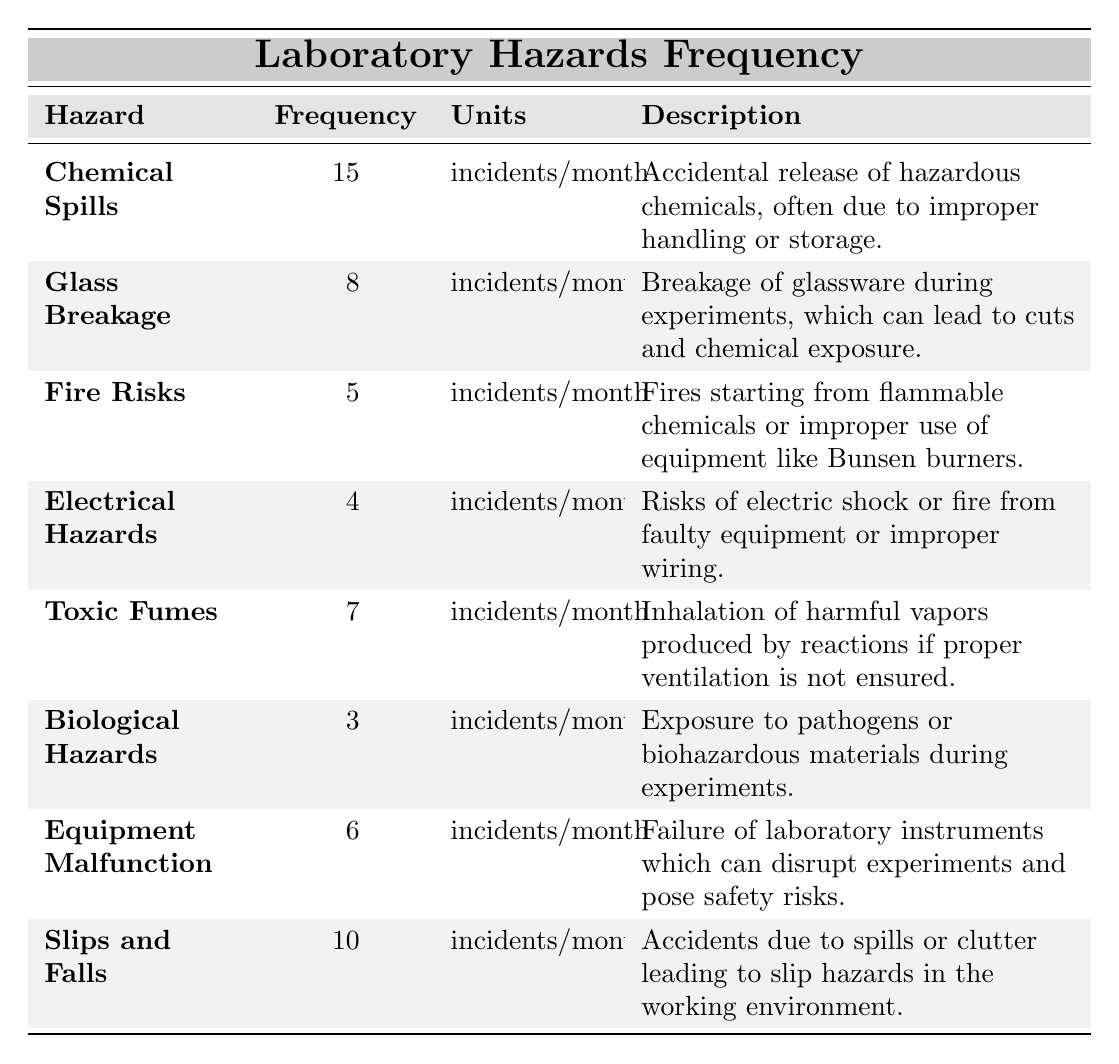What is the most frequent laboratory hazard? The table shows that "Chemical Spills" have the highest frequency at 15 incidents per month.
Answer: Chemical Spills How many incidents of "Glass Breakage" are reported each month? The table indicates that there are 8 incidents of "Glass Breakage" each month.
Answer: 8 incidents Are "Electrical Hazards" more frequent than "Fire Risks"? "Electrical Hazards" occur 4 times per month, while "Fire Risks" occur 5 times per month, thus "Electrical Hazards" are not more frequent.
Answer: No What is the total number of incidents for the top three hazards? The top three hazards are "Chemical Spills" (15), "Slips and Falls" (10), and "Glass Breakage" (8). Total incidents = 15 + 10 + 8 = 33.
Answer: 33 What is the frequency of "Toxic Fumes"? The table states that "Toxic Fumes" have a frequency of 7 incidents per month.
Answer: 7 incidents Which hazard has the lowest frequency and what is its value? The lowest frequency is for "Biological Hazards," which is reported at 3 incidents per month.
Answer: 3 incidents What is the average frequency of all hazards listed? To find the average, sum all frequencies: 15 + 8 + 5 + 4 + 7 + 3 + 6 + 10 = 58. There are 8 hazards, so the average is 58 / 8 = 7.25.
Answer: 7.25 incidents Is the frequency of "Equipment Malfunction" greater than or equal to the sum of "Fire Risks" and "Electrical Hazards"? "Equipment Malfunction" has a frequency of 6, while "Fire Risks" (5) + "Electrical Hazards" (4) sum to 9. Therefore, 6 is less than 9.
Answer: No How many more incidents occur from "Slips and Falls" than from "Biological Hazards"? "Slips and Falls" have 10 incidents, while "Biological Hazards" have 3 incidents. The difference is 10 - 3 = 7 incidents.
Answer: 7 incidents What percentage of the total incidents does "Chemical Spills" represent? Total incidents = 58. "Chemical Spills" have 15 incidents. The percentage is (15 / 58) * 100 = 25.86%.
Answer: 25.86% 